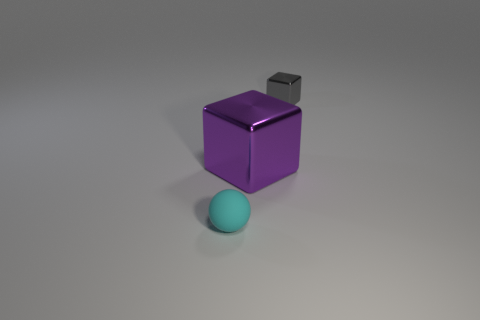What material is the other object that is the same size as the gray shiny object?
Make the answer very short. Rubber. What size is the thing that is to the left of the gray metal cube and right of the cyan matte sphere?
Ensure brevity in your answer.  Large. What color is the thing that is to the right of the rubber sphere and left of the tiny metallic cube?
Offer a very short reply. Purple. Is the number of shiny cubes to the right of the small shiny object less than the number of cyan spheres to the right of the purple shiny block?
Make the answer very short. No. What number of other things have the same shape as the small shiny object?
Make the answer very short. 1. There is a gray thing that is made of the same material as the big purple object; what is its size?
Your response must be concise. Small. What is the color of the tiny thing behind the tiny thing that is in front of the tiny gray metal thing?
Your answer should be very brief. Gray. There is a rubber thing; is its shape the same as the metal thing that is on the left side of the gray thing?
Your response must be concise. No. What number of purple shiny things have the same size as the purple shiny cube?
Make the answer very short. 0. What is the material of the purple object that is the same shape as the small gray thing?
Ensure brevity in your answer.  Metal. 